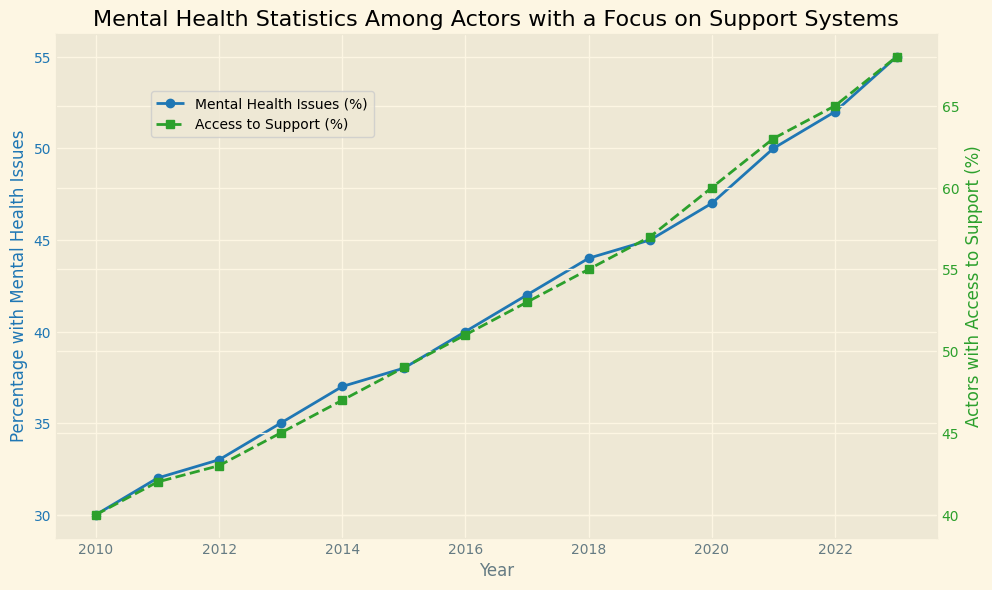What's the difference in the percentage of actors with mental health issues between 2010 and 2023? In 2010, the percentage of actors with mental health issues was 30%. In 2023, it was 55%. The difference is 55% - 30% = 25%.
Answer: 25% Which year shows the highest percentage of actors with access to support? By observing the secondary y-axis (green line with square markers), it is highest in 2023, where the percentage is 68%.
Answer: 2023 Between which consecutive years did the percentage of actors with mental health issues increase the most? Looking at the blue line with circular markers, the percentage increased most between 2021 and 2022, from 50% to 52%, a change of 2%.
Answer: 2021-2022 Describe the trend in access to support for actors from 2010 to 2023. The green line with square markers shows an increasing trend in the percentage of actors with access to support from 40% in 2010 to 68% in 2023.
Answer: Increasing trend Is there a year where the percentage of actors with mental health issues is equal to the percentage of actors with access to support? No, throughout all the years depicted, no single year has equal percentages for both metrics.
Answer: No What is the average percentage of actors with mental health issues from 2010 to 2023? Sum the percentages (30 + 32 + 33 + 35 + 37 + 38 + 40 + 42 + 44 + 45 + 47 + 50 + 52 + 55 = 580) and divide by the number of years (2023-2010+1 = 14). The average is 580 / 14 ≈ 41.43%
Answer: ~41.43% How does the percentage of actors with access to support in 2020 compare to 2010? In 2020, the percentage was 60%, and in 2010, it was 40%. The comparison shows 60% > 40%.
Answer: 60% > 40% What is the percentage increase in actors with access to support from the first year to the last? In 2010, it was 40%. In 2023, it was 68%. The increase is calculated as ((68-40)/40)*100 = 70%.
Answer: 70% Which visual attribute indicates mental health issues in the chart? The blue line with circular markers represents the percentage of actors with mental health issues.
Answer: Blue line with circular markers 